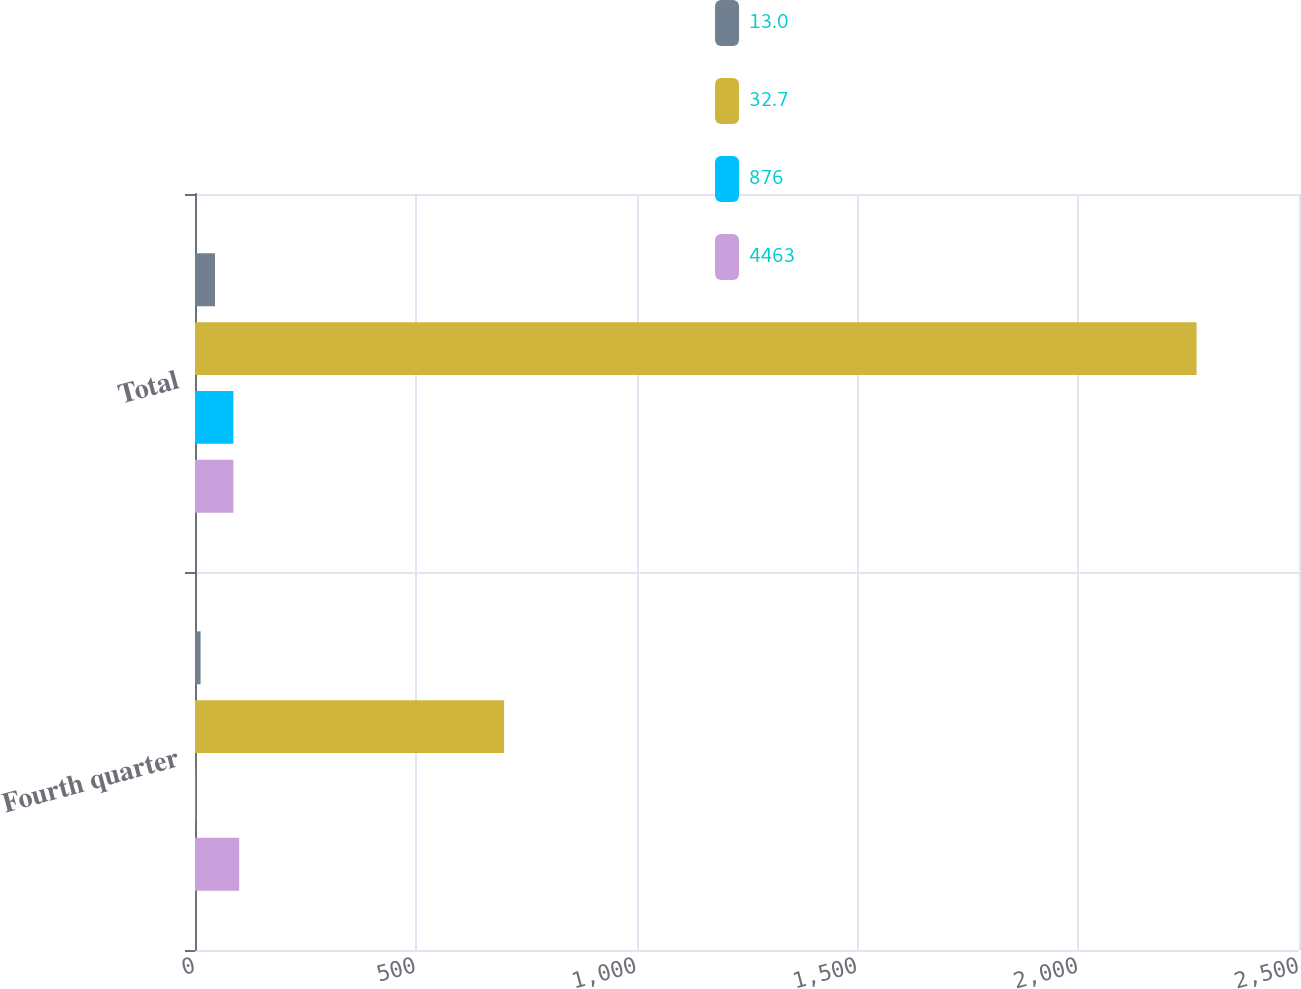Convert chart to OTSL. <chart><loc_0><loc_0><loc_500><loc_500><stacked_bar_chart><ecel><fcel>Fourth quarter<fcel>Total<nl><fcel>13<fcel>12.6<fcel>45.3<nl><fcel>32.7<fcel>700<fcel>2268<nl><fcel>876<fcel>1.8<fcel>87<nl><fcel>4463<fcel>100<fcel>87<nl></chart> 